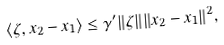Convert formula to latex. <formula><loc_0><loc_0><loc_500><loc_500>\langle \zeta , x _ { 2 } - x _ { 1 } \rangle \leq \gamma ^ { \prime } \| \zeta \| \| x _ { 2 } - x _ { 1 } \| ^ { 2 } ,</formula> 